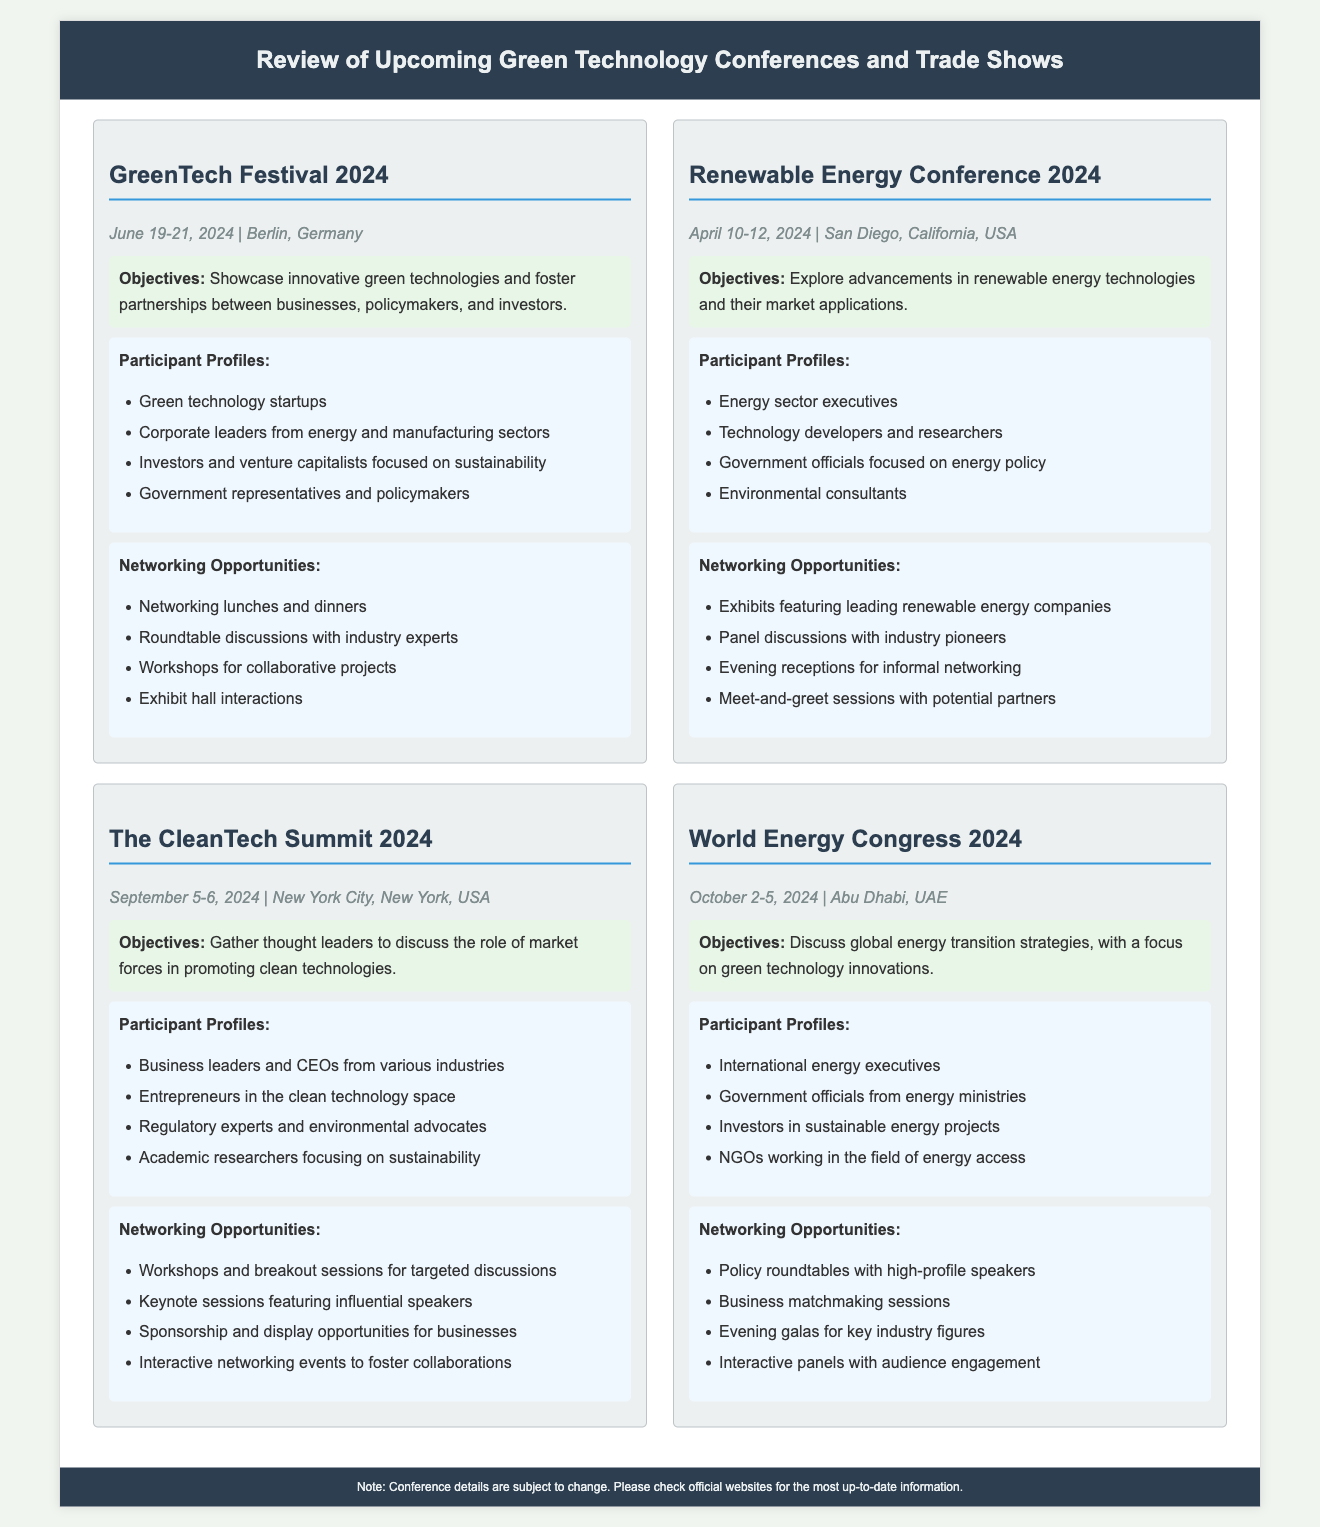what is the date of the GreenTech Festival 2024? The date for the GreenTech Festival 2024 is provided in the document as June 19-21, 2024.
Answer: June 19-21, 2024 who are the primary participants at the Renewable Energy Conference 2024? The document lists participant profiles, and for the Renewable Energy Conference, they include energy sector executives and technology developers.
Answer: Energy sector executives what is the main objective of The CleanTech Summit 2024? The main objective is explicitly stated in the document, which is to gather thought leaders to discuss the role of market forces in promoting clean technologies.
Answer: Discuss market forces how many networking opportunities are listed for the World Energy Congress 2024? The document provides a list of networking opportunities for the World Energy Congress, which includes four specified opportunities.
Answer: Four which city will host the Renewable Energy Conference 2024? The hosting city is indicated in the document, which states San Diego, California, USA, as the location for the Renewable Energy Conference 2024.
Answer: San Diego, California, USA what type of events are included in networking opportunities at the GreenTech Festival 2024? The document lists networking opportunities, which include lunches, dinners, and roundtable discussions, among other types of events.
Answer: Networking lunches and dinners who will likely attend The CleanTech Summit 2024 based on the participant profiles? The participant profiles for The CleanTech Summit include business leaders and CEOs, indicating they will likely attend.
Answer: Business leaders and CEOs what is the date range of the World Energy Congress 2024? The document mentions the date range for the World Energy Congress, which is October 2-5, 2024.
Answer: October 2-5, 2024 what opportunities are available for businesses at The CleanTech Summit 2024? The document specifies sponsorship and display opportunities for businesses, highlighting what they can do at the event.
Answer: Sponsorship and display opportunities 